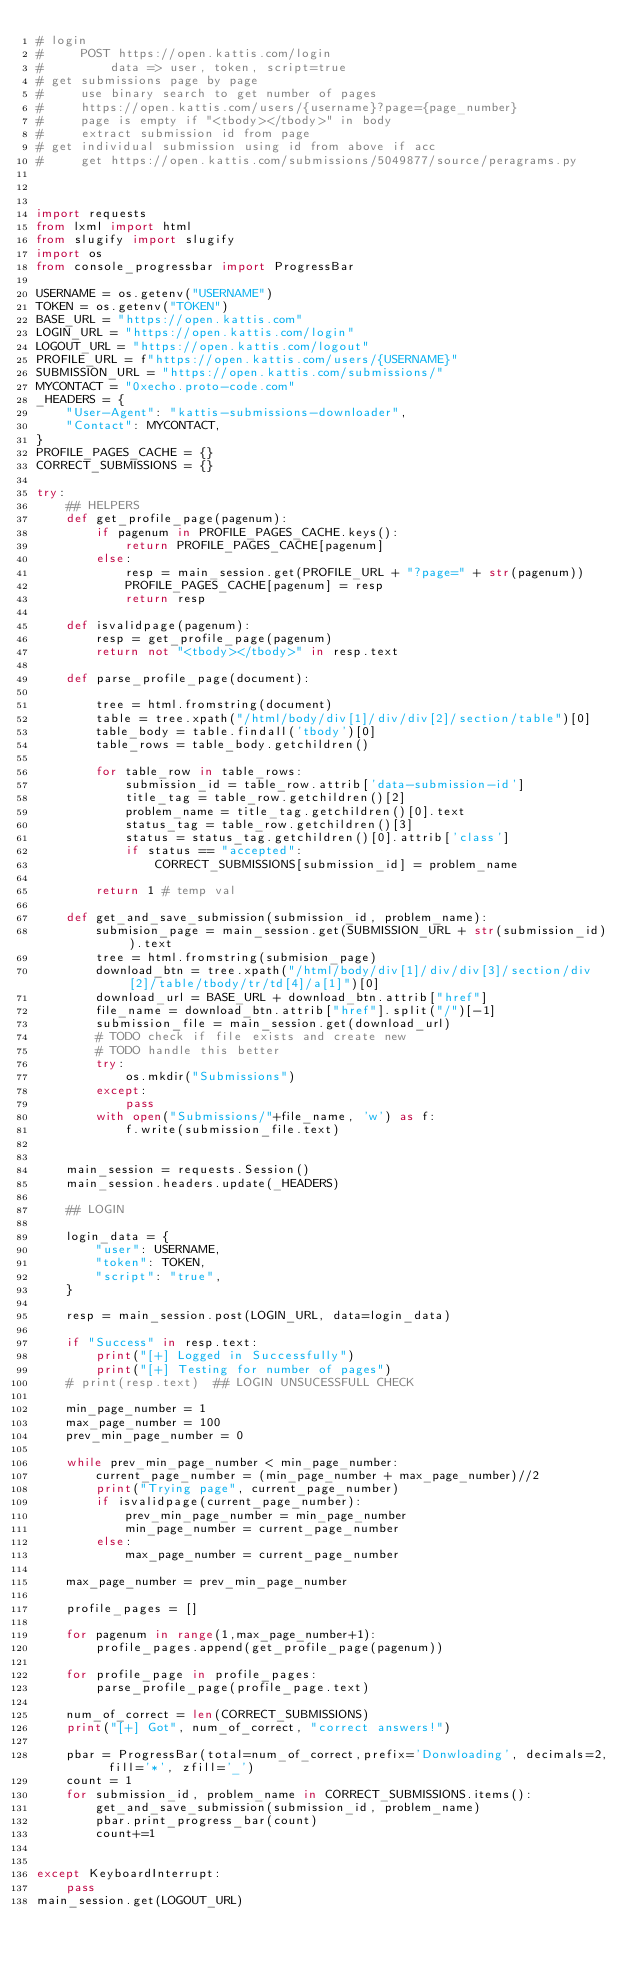<code> <loc_0><loc_0><loc_500><loc_500><_Python_># login
#     POST https://open.kattis.com/login
#         data => user, token, script=true
# get submissions page by page
#     use binary search to get number of pages
#     https://open.kattis.com/users/{username}?page={page_number}
#     page is empty if "<tbody></tbody>" in body
#     extract submission id from page
# get individual submission using id from above if acc
#     get https://open.kattis.com/submissions/5049877/source/peragrams.py



import requests
from lxml import html
from slugify import slugify
import os
from console_progressbar import ProgressBar

USERNAME = os.getenv("USERNAME")
TOKEN = os.getenv("TOKEN")
BASE_URL = "https://open.kattis.com"
LOGIN_URL = "https://open.kattis.com/login"
LOGOUT_URL = "https://open.kattis.com/logout"
PROFILE_URL = f"https://open.kattis.com/users/{USERNAME}"
SUBMISSION_URL = "https://open.kattis.com/submissions/"
MYCONTACT = "0xecho.proto-code.com"
_HEADERS = {
    "User-Agent": "kattis-submissions-downloader",
    "Contact": MYCONTACT,
}
PROFILE_PAGES_CACHE = {}
CORRECT_SUBMISSIONS = {}

try:
    ## HELPERS
    def get_profile_page(pagenum):
        if pagenum in PROFILE_PAGES_CACHE.keys():
            return PROFILE_PAGES_CACHE[pagenum]
        else:
            resp = main_session.get(PROFILE_URL + "?page=" + str(pagenum))
            PROFILE_PAGES_CACHE[pagenum] = resp
            return resp
    
    def isvalidpage(pagenum):
        resp = get_profile_page(pagenum)
        return not "<tbody></tbody>" in resp.text
        
    def parse_profile_page(document):
    
        tree = html.fromstring(document)
        table = tree.xpath("/html/body/div[1]/div/div[2]/section/table")[0]
        table_body = table.findall('tbody')[0]
        table_rows = table_body.getchildren()
        
        for table_row in table_rows:
            submission_id = table_row.attrib['data-submission-id']
            title_tag = table_row.getchildren()[2]
            problem_name = title_tag.getchildren()[0].text
            status_tag = table_row.getchildren()[3]
            status = status_tag.getchildren()[0].attrib['class']
            if status == "accepted":
                CORRECT_SUBMISSIONS[submission_id] = problem_name

        return 1 # temp val
    
    def get_and_save_submission(submission_id, problem_name):
        submision_page = main_session.get(SUBMISSION_URL + str(submission_id)).text
        tree = html.fromstring(submision_page)
        download_btn = tree.xpath("/html/body/div[1]/div/div[3]/section/div[2]/table/tbody/tr/td[4]/a[1]")[0]
        download_url = BASE_URL + download_btn.attrib["href"]
        file_name = download_btn.attrib["href"].split("/")[-1]
        submission_file = main_session.get(download_url)
        # TODO check if file exists and create new
        # TODO handle this better
        try:
            os.mkdir("Submissions")
        except:
            pass
        with open("Submissions/"+file_name, 'w') as f:
            f.write(submission_file.text)
        
        
    main_session = requests.Session()
    main_session.headers.update(_HEADERS)
    
    ## LOGIN
    
    login_data = {
        "user": USERNAME,
        "token": TOKEN,
        "script": "true",
    }
    
    resp = main_session.post(LOGIN_URL, data=login_data)
    
    if "Success" in resp.text:
        print("[+] Logged in Successfully")
        print("[+] Testing for number of pages")
    # print(resp.text)  ## LOGIN UNSUCESSFULL CHECK
    
    min_page_number = 1
    max_page_number = 100
    prev_min_page_number = 0
    
    while prev_min_page_number < min_page_number:
        current_page_number = (min_page_number + max_page_number)//2
        print("Trying page", current_page_number)
        if isvalidpage(current_page_number):
            prev_min_page_number = min_page_number 
            min_page_number = current_page_number
        else:
            max_page_number = current_page_number
    
    max_page_number = prev_min_page_number
    
    profile_pages = []
    
    for pagenum in range(1,max_page_number+1):
        profile_pages.append(get_profile_page(pagenum))
    
    for profile_page in profile_pages:        
        parse_profile_page(profile_page.text)
    
    num_of_correct = len(CORRECT_SUBMISSIONS)
    print("[+] Got", num_of_correct, "correct answers!")
    
    pbar = ProgressBar(total=num_of_correct,prefix='Donwloading', decimals=2, fill='*', zfill='_')
    count = 1
    for submission_id, problem_name in CORRECT_SUBMISSIONS.items():
        get_and_save_submission(submission_id, problem_name)
        pbar.print_progress_bar(count)
        count+=1
        
    
except KeyboardInterrupt:
    pass
main_session.get(LOGOUT_URL)
</code> 